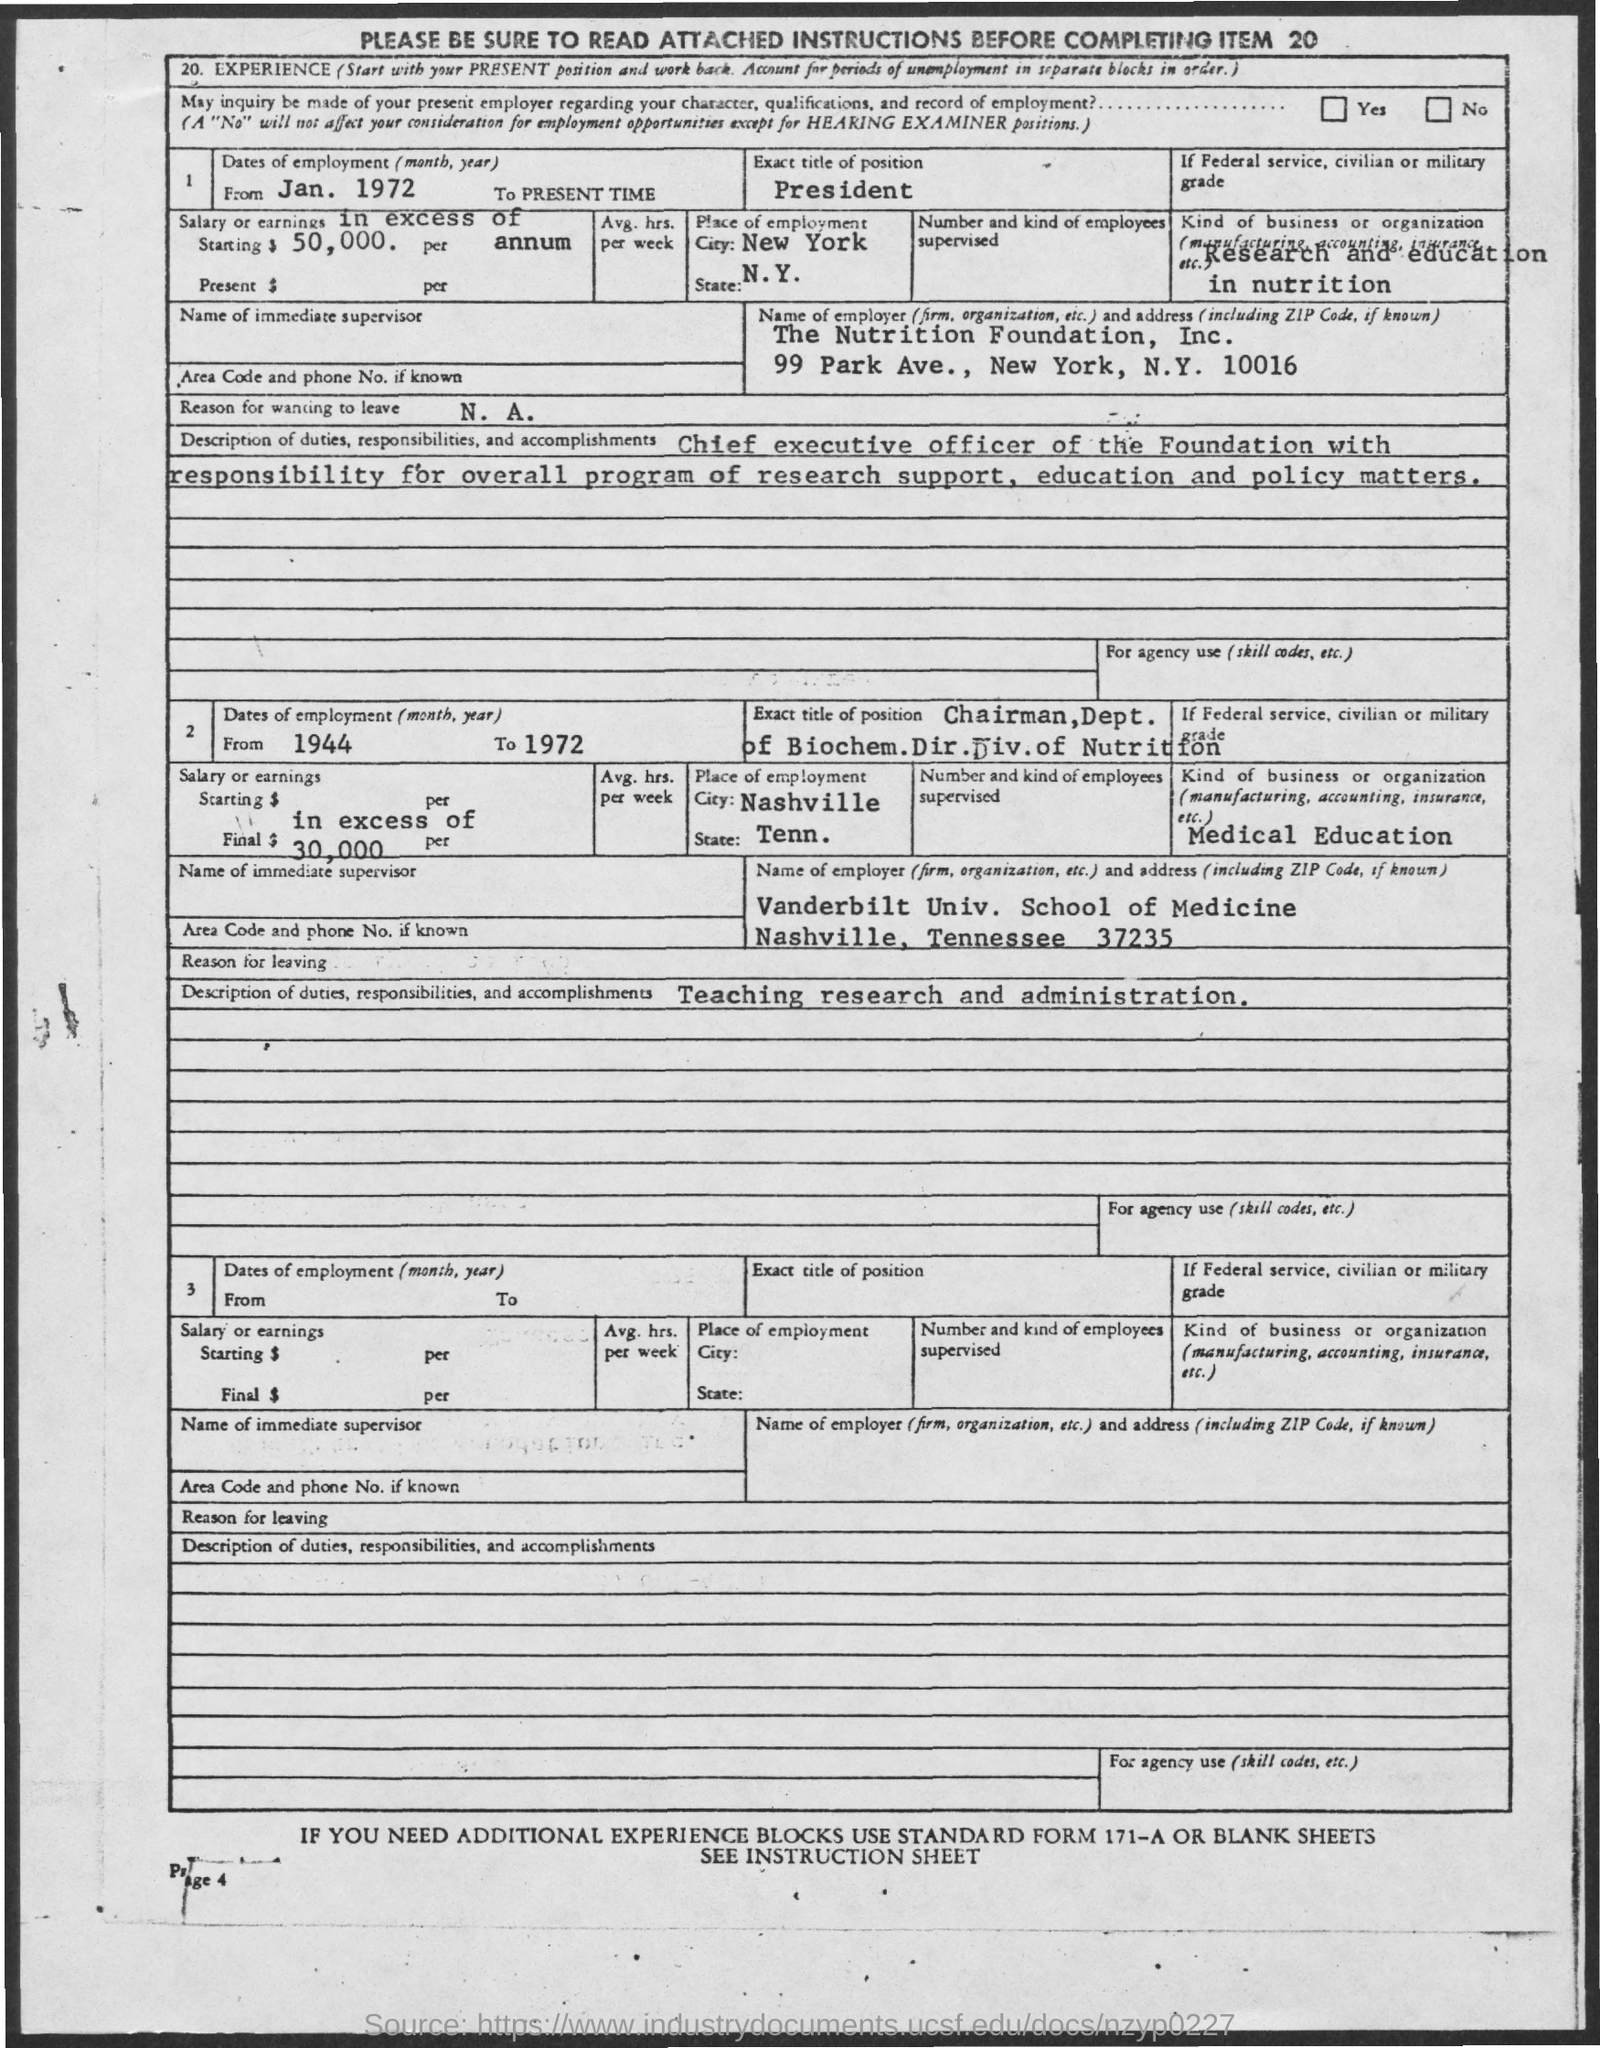What is the address of the nutrition foundation , inc
Ensure brevity in your answer.  99 Park Ave., New York, N.Y. 10016. 